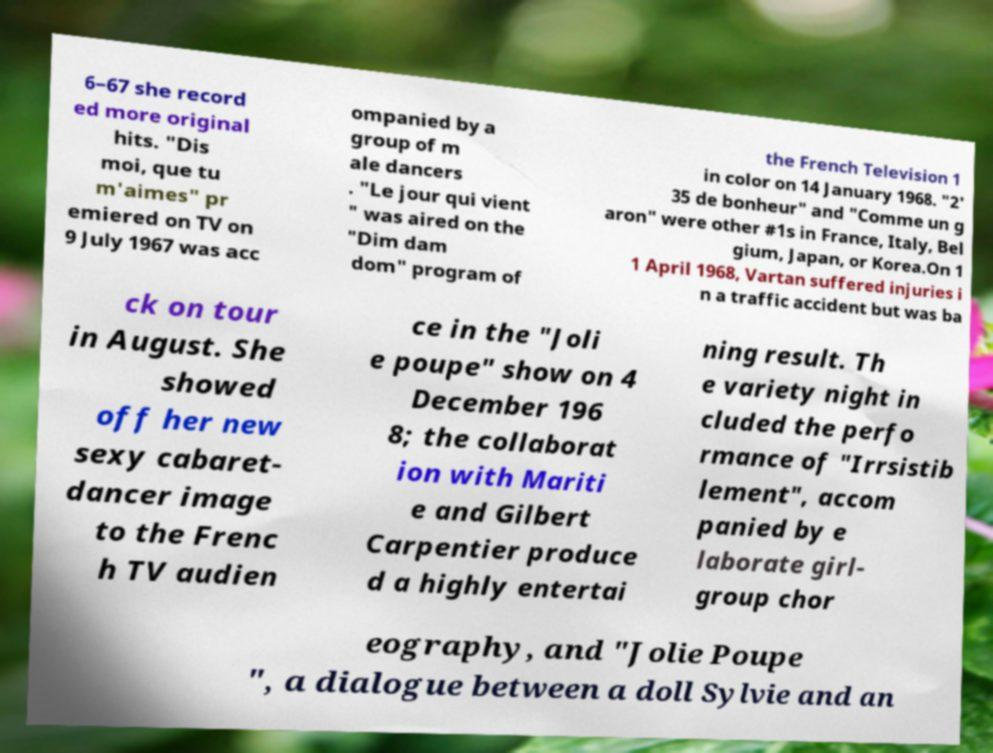What messages or text are displayed in this image? I need them in a readable, typed format. 6–67 she record ed more original hits. "Dis moi, que tu m'aimes" pr emiered on TV on 9 July 1967 was acc ompanied by a group of m ale dancers . "Le jour qui vient " was aired on the "Dim dam dom" program of the French Television 1 in color on 14 January 1968. "2' 35 de bonheur" and "Comme un g aron" were other #1s in France, Italy, Bel gium, Japan, or Korea.On 1 1 April 1968, Vartan suffered injuries i n a traffic accident but was ba ck on tour in August. She showed off her new sexy cabaret- dancer image to the Frenc h TV audien ce in the "Joli e poupe" show on 4 December 196 8; the collaborat ion with Mariti e and Gilbert Carpentier produce d a highly entertai ning result. Th e variety night in cluded the perfo rmance of "Irrsistib lement", accom panied by e laborate girl- group chor eography, and "Jolie Poupe ", a dialogue between a doll Sylvie and an 